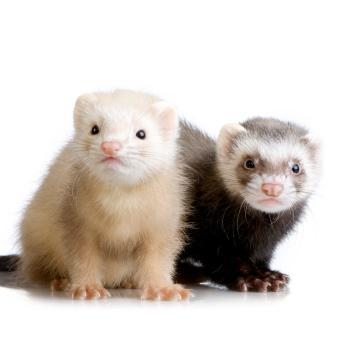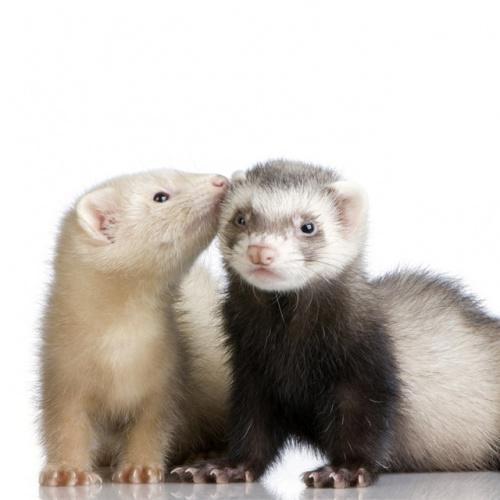The first image is the image on the left, the second image is the image on the right. For the images displayed, is the sentence "The left image contains more ferrets than the right image." factually correct? Answer yes or no. No. 